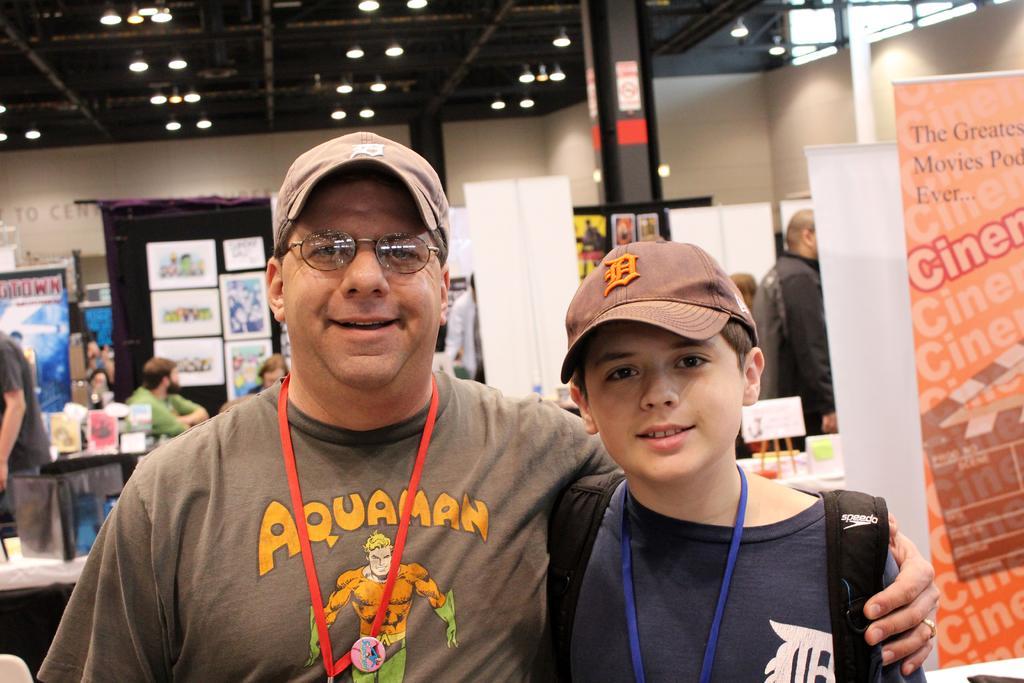Please provide a concise description of this image. This image is taken indoors. In the background there is a wall. There are many boards and posters with text on them. At the top of the image there is a roof and there are many lights. There is a pillar. On the right side of the image there is a banner with a text on it. In the middle of the image there are many tables with many things on them. A few people are standing and a few are sitting. There is a man and there is a boy. 